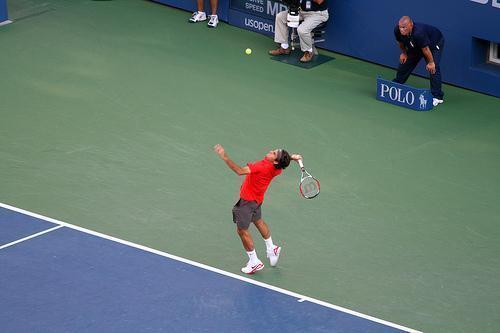How many people are there?
Give a very brief answer. 4. 